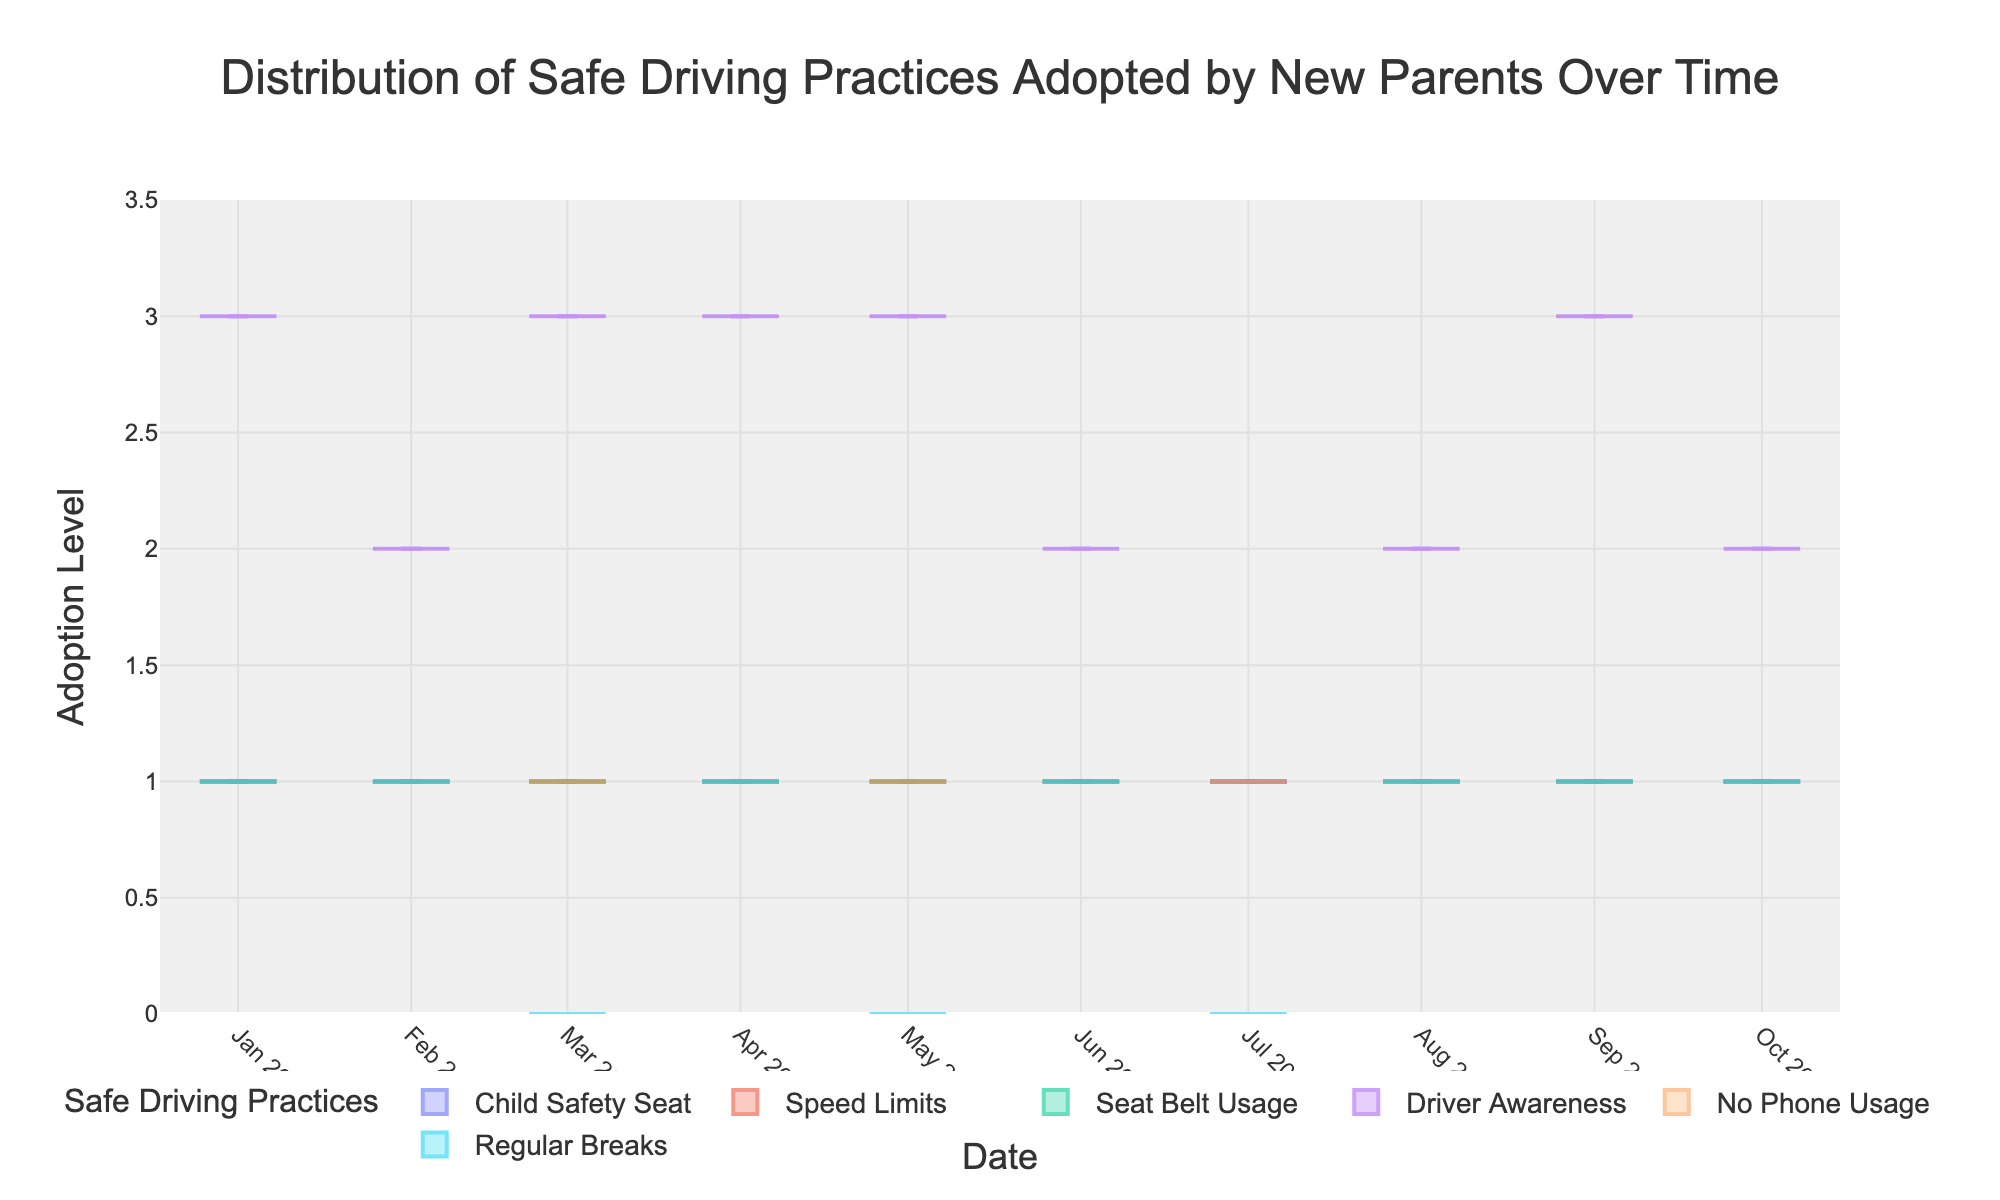What is the title of the plot? The title is displayed at the top of the plot and it provides a descriptive summary of the data being visualized.
Answer: Distribution of Safe Driving Practices Adopted by New Parents Over Time What is the adoption level range for safe driving practices in this plot? The adoption level range is shown on the y-axis, indicating the possible values from the lowest to the highest.
Answer: 0 to 3.5 How does the 'Driver Awareness' practice vary over time? By observing the violin plot for 'Driver Awareness', we can see the changes in its distribution and mean values over the different dates on the x-axis.
Answer: It varies between Low (1), Medium (2), and High (3) Which safe driving practice shows the least variation over time? To identify the practice with the least variation, we look for the violin plot with the smallest spread or most consistent box and mean line.
Answer: Child Safety Seat Between the dates March 2023 and July 2023, how often was 'Regular Breaks' not adopted? To figure this out, we need to count instances where the 'Regular Breaks' value is 0 (No) during the specified period.
Answer: 3 times Does the 'No Phone Usage' practice show consistent adoption over time? Examine the violin plot for 'No Phone Usage' to determine if there are any significant variations or if the mean line remains steady over time.
Answer: Yes, it shows consistent adoption Which month recorded the lowest driver awareness? Look for the point on the 'Driver Awareness' violin plot where the lowest value (1 for Low) appears and identify the corresponding date on the x-axis.
Answer: July 2023 How many practices were consistently adopted every month? A consistent practice would display a violin plot with no or very minimal spread, indicating that it was always adopted.
Answer: 4 practices During which month was 'Driver Awareness' set at 'Medium'? Check the dates on the x-axis corresponding to when the 'Driver Awareness' value is at Medium (2).
Answer: February, June, August, October 2023 What is the difference in 'Driver Awareness' levels between January 2023 and July 2023? Subtract the 'Driver Awareness' level in January (3 for High) from the level in July (1 for Low).
Answer: 2 